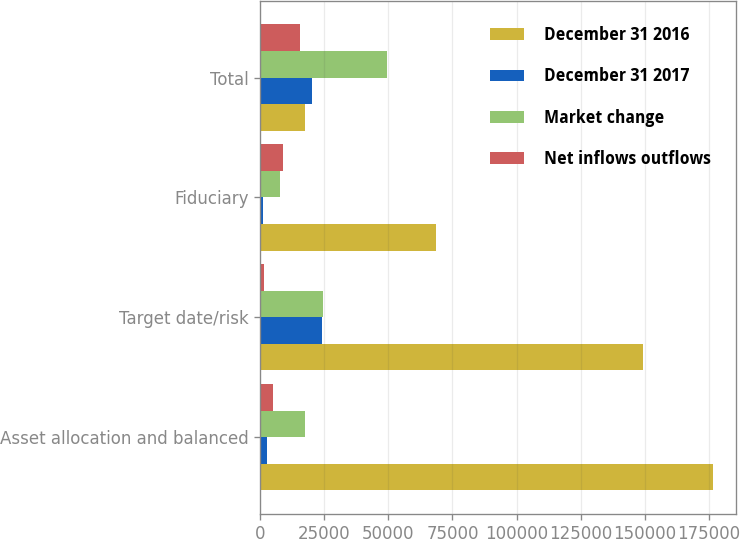Convert chart to OTSL. <chart><loc_0><loc_0><loc_500><loc_500><stacked_bar_chart><ecel><fcel>Asset allocation and balanced<fcel>Target date/risk<fcel>Fiduciary<fcel>Total<nl><fcel>December 31 2016<fcel>176675<fcel>149432<fcel>68395<fcel>17387<nl><fcel>December 31 2017<fcel>2502<fcel>23925<fcel>1047<fcel>20330<nl><fcel>Market change<fcel>17387<fcel>24532<fcel>7522<fcel>49560<nl><fcel>Net inflows outflows<fcel>4985<fcel>1577<fcel>8819<fcel>15381<nl></chart> 